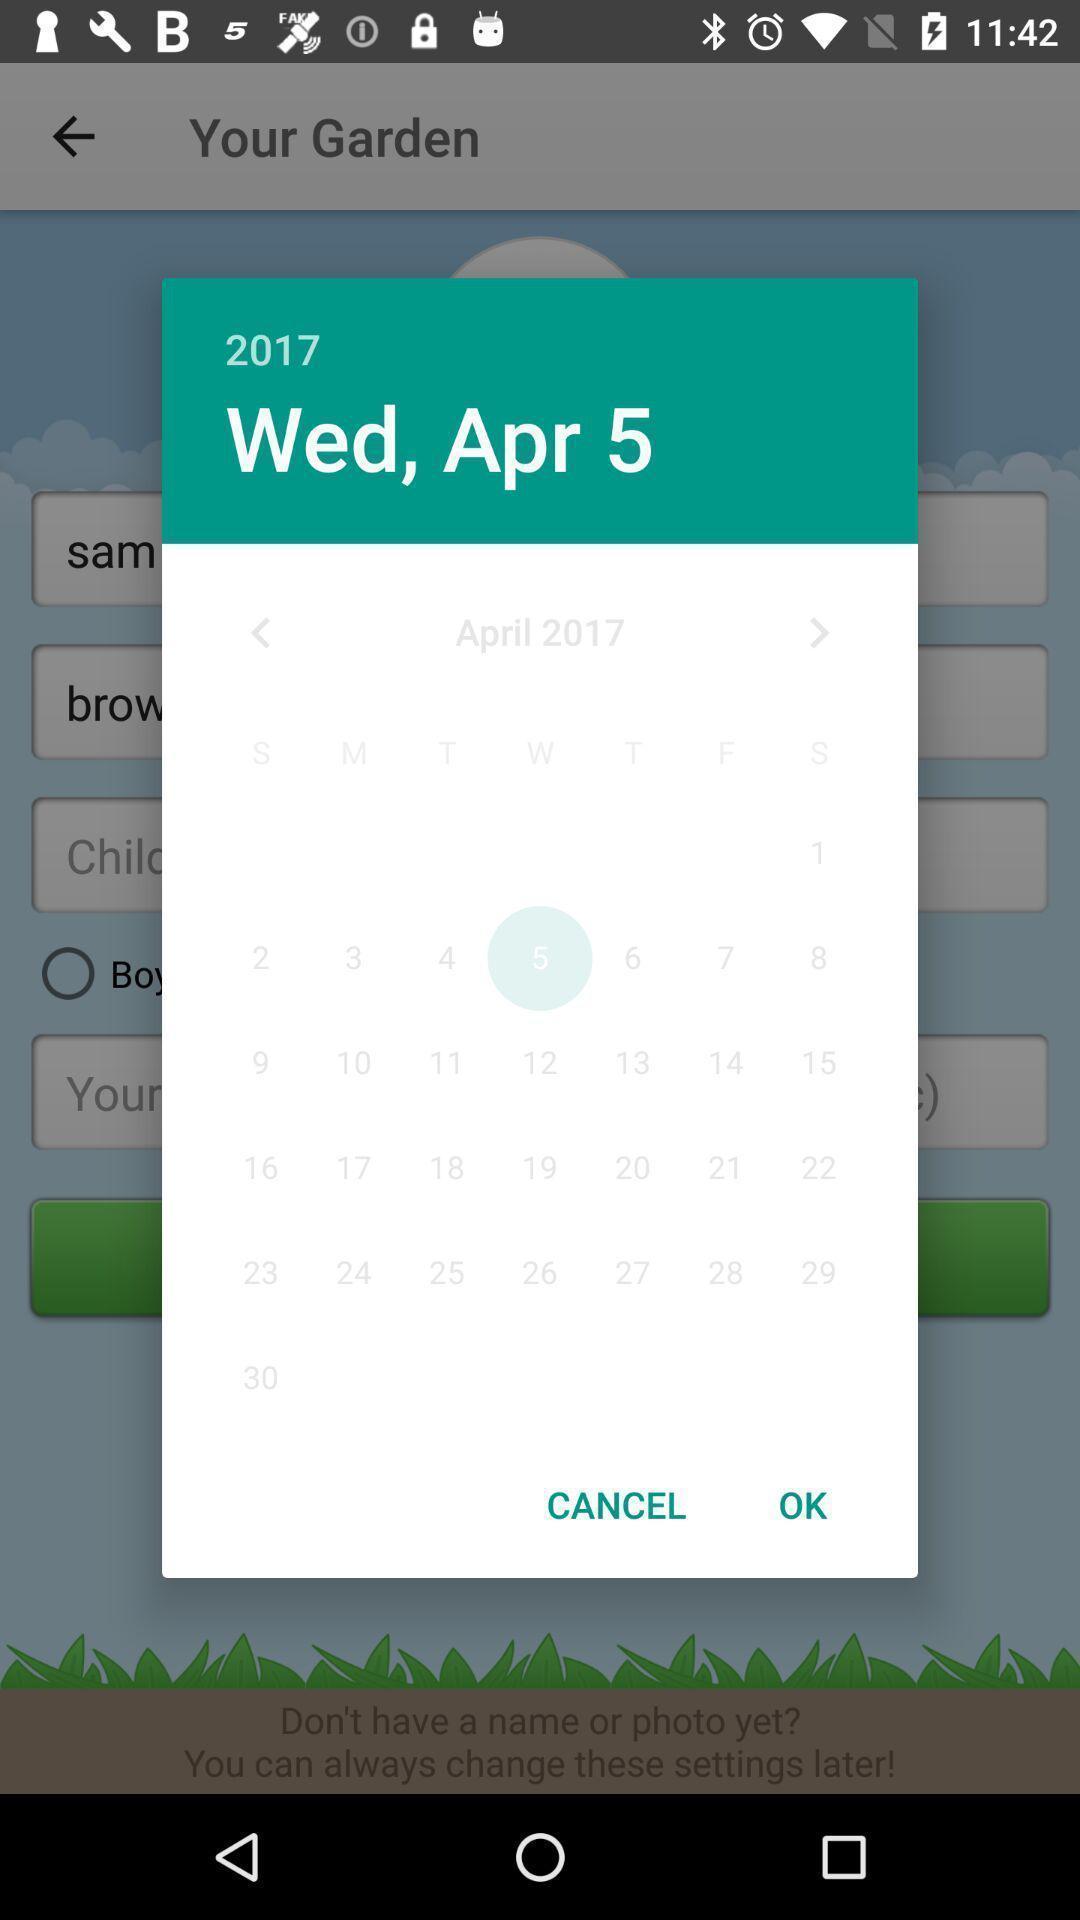Summarize the main components in this picture. Pop up showing different dates. 